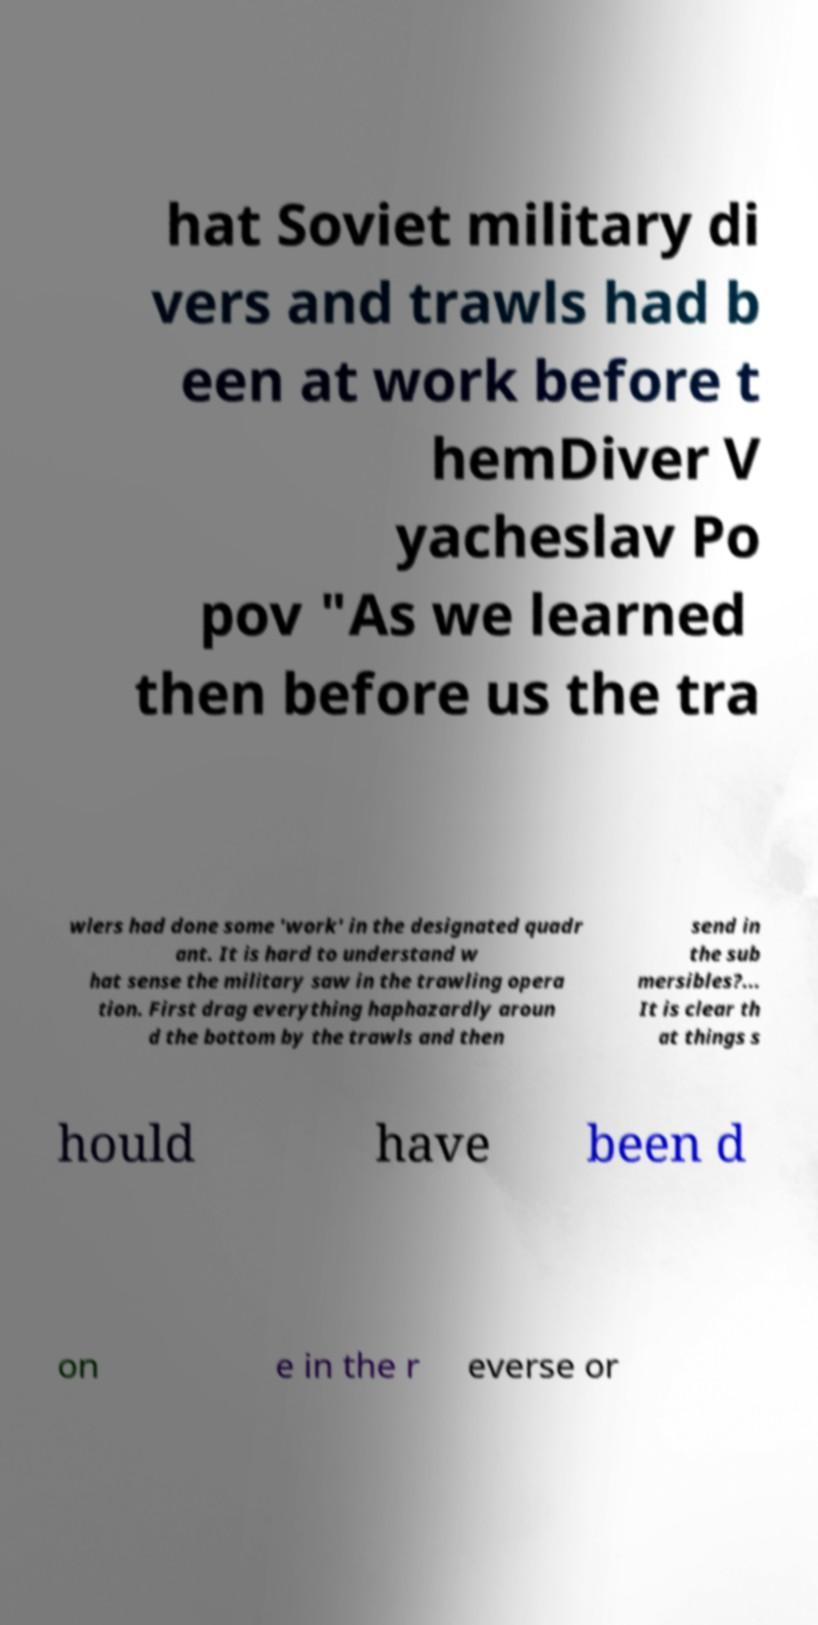Could you extract and type out the text from this image? hat Soviet military di vers and trawls had b een at work before t hemDiver V yacheslav Po pov "As we learned then before us the tra wlers had done some 'work' in the designated quadr ant. It is hard to understand w hat sense the military saw in the trawling opera tion. First drag everything haphazardly aroun d the bottom by the trawls and then send in the sub mersibles?... It is clear th at things s hould have been d on e in the r everse or 